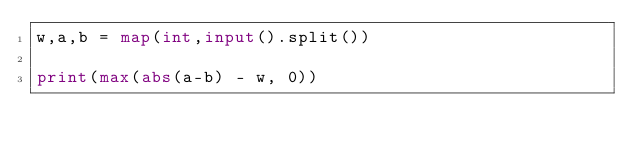<code> <loc_0><loc_0><loc_500><loc_500><_Python_>w,a,b = map(int,input().split())

print(max(abs(a-b) - w, 0))</code> 